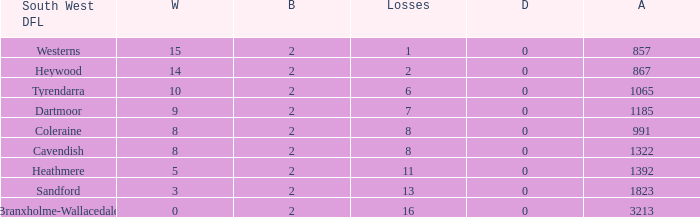How many Draws have a South West DFL of tyrendarra, and less than 10 wins? None. 